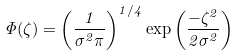Convert formula to latex. <formula><loc_0><loc_0><loc_500><loc_500>\Phi ( \zeta ) = \left ( \frac { 1 } { \sigma ^ { 2 } \pi } \right ) ^ { 1 / 4 } \exp \left ( \frac { - \zeta ^ { 2 } } { 2 \sigma ^ { 2 } } \right )</formula> 